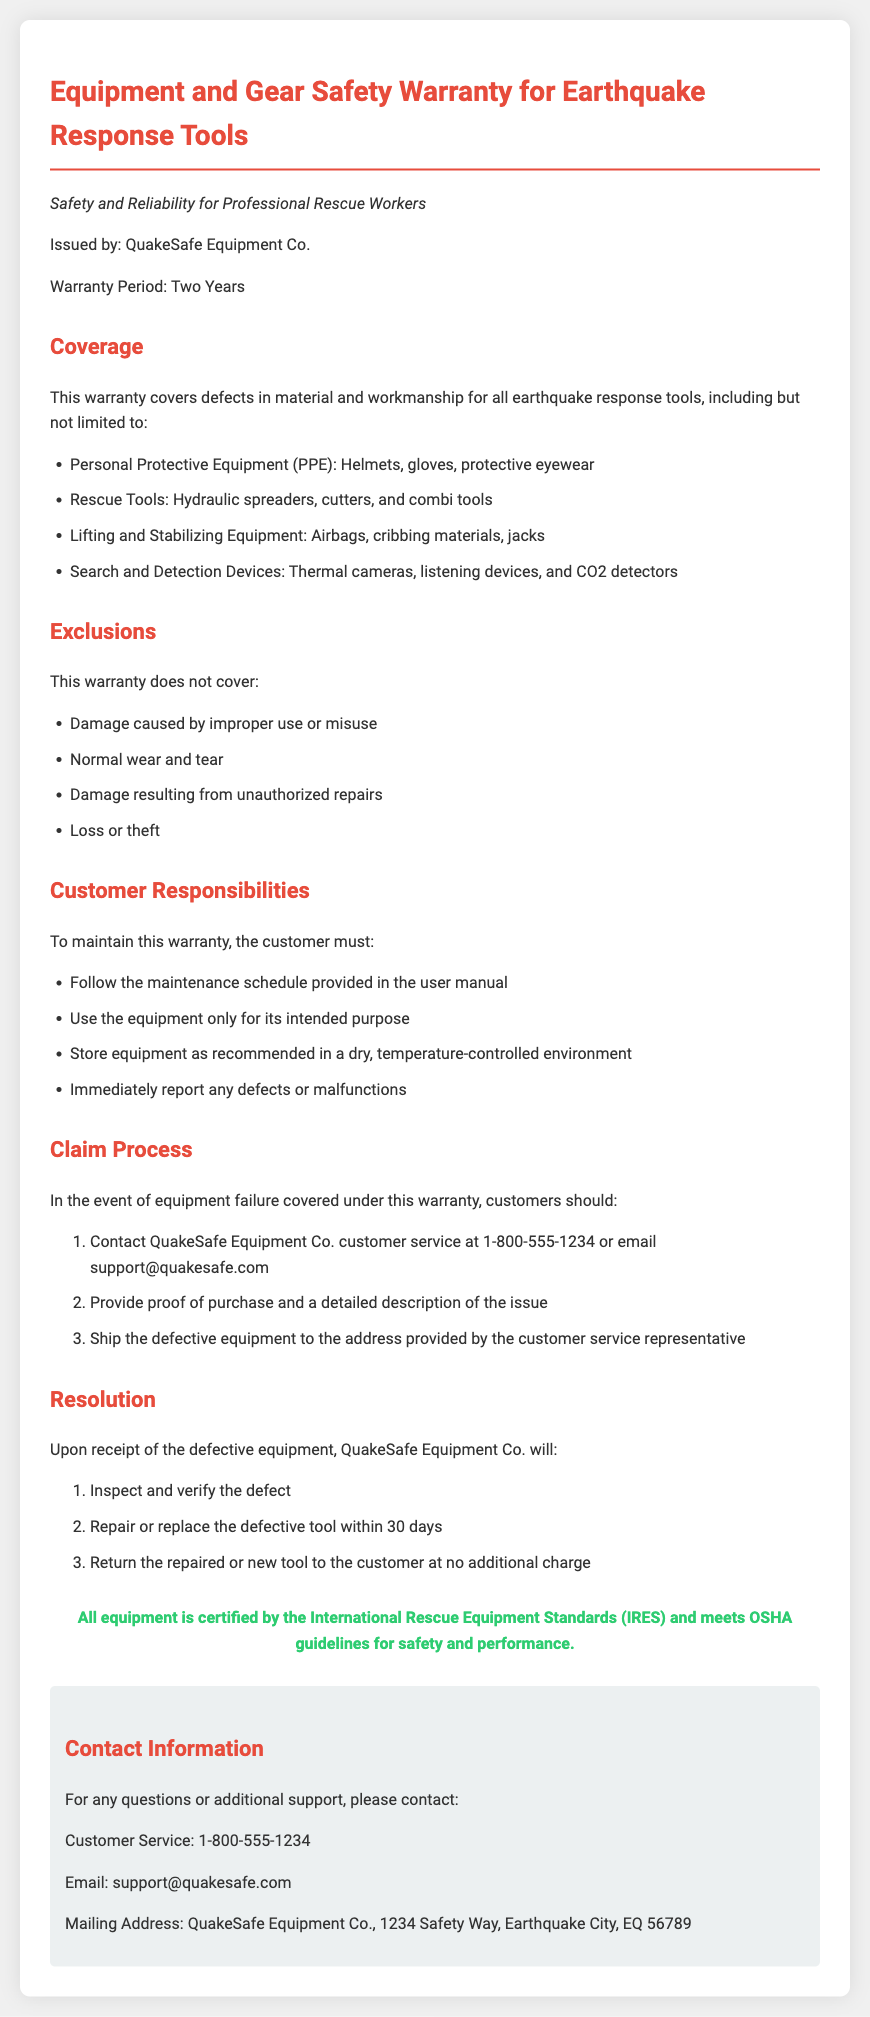What is the warranty period for earthquake response tools? The warranty period is explicitly stated in the document as two years.
Answer: Two Years Who issued the warranty? The document specifies that the warranty is issued by QuakeSafe Equipment Co.
Answer: QuakeSafe Equipment Co What types of equipment are covered under this warranty? The document lists specific categories of equipment, such as PPE, Rescue Tools, etc.
Answer: Personal Protective Equipment, Rescue Tools, Lifting and Stabilizing Equipment, Search and Detection Devices What should customers do if they notice a defect? The responsibilities section highlights reporting any defects or malfunctions immediately.
Answer: Immediately report any defects or malfunctions What is excluded from the warranty coverage? The document provides a list of exclusions, which includes terms like "normal wear and tear."
Answer: Damage caused by improper use or misuse How long does QuakeSafe Equipment Co. take to repair or replace defective tools? The resolution section mentions a specific timeframe for repair or replacement after inspection.
Answer: Within 30 days What is required to initiate a claim? The claim process outlines needed actions, including proof of purchase and issue description.
Answer: Proof of purchase and a detailed description of the issue Where can customers find contact information for support? There is a dedicated contact information section providing various means to reach customer service.
Answer: Customer Service: 1-800-555-1234; Email: support@quakesafe.com 